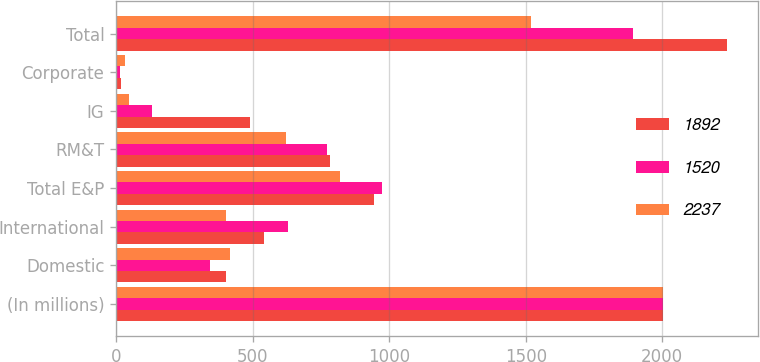<chart> <loc_0><loc_0><loc_500><loc_500><stacked_bar_chart><ecel><fcel>(In millions)<fcel>Domestic<fcel>International<fcel>Total E&P<fcel>RM&T<fcel>IG<fcel>Corporate<fcel>Total<nl><fcel>1892<fcel>2004<fcel>402<fcel>542<fcel>944<fcel>784<fcel>490<fcel>19<fcel>2237<nl><fcel>1520<fcel>2003<fcel>344<fcel>629<fcel>973<fcel>772<fcel>131<fcel>16<fcel>1892<nl><fcel>2237<fcel>2002<fcel>417<fcel>403<fcel>820<fcel>621<fcel>48<fcel>31<fcel>1520<nl></chart> 